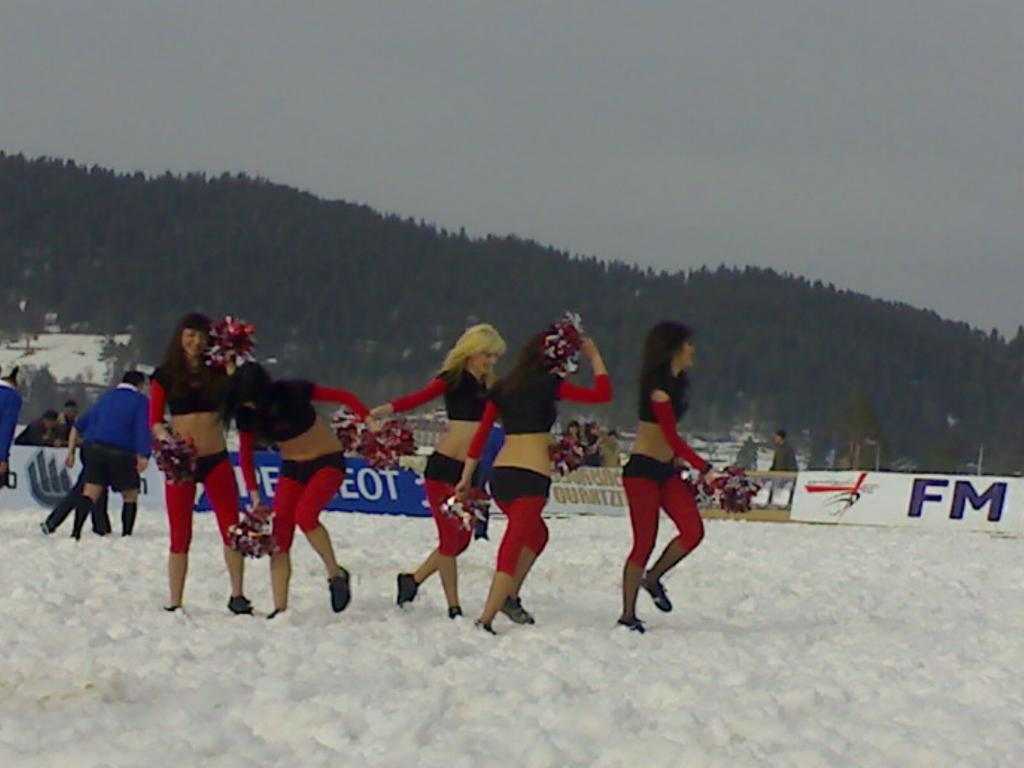How many people are standing on the snow in the image? There are five people standing on the snow in the image. Can you describe the people in the background? There are other people in the background, but their specific number or actions are not mentioned in the facts. What is the banner in the image? The facts do not provide information about the content or purpose of the banner. What can be seen in the background of the image? There is a mountain in the background, and the sky is clear. Can you tell me the direction the cat is facing in the image? There is no cat present in the image, so it is not possible to determine the direction it might be facing. 